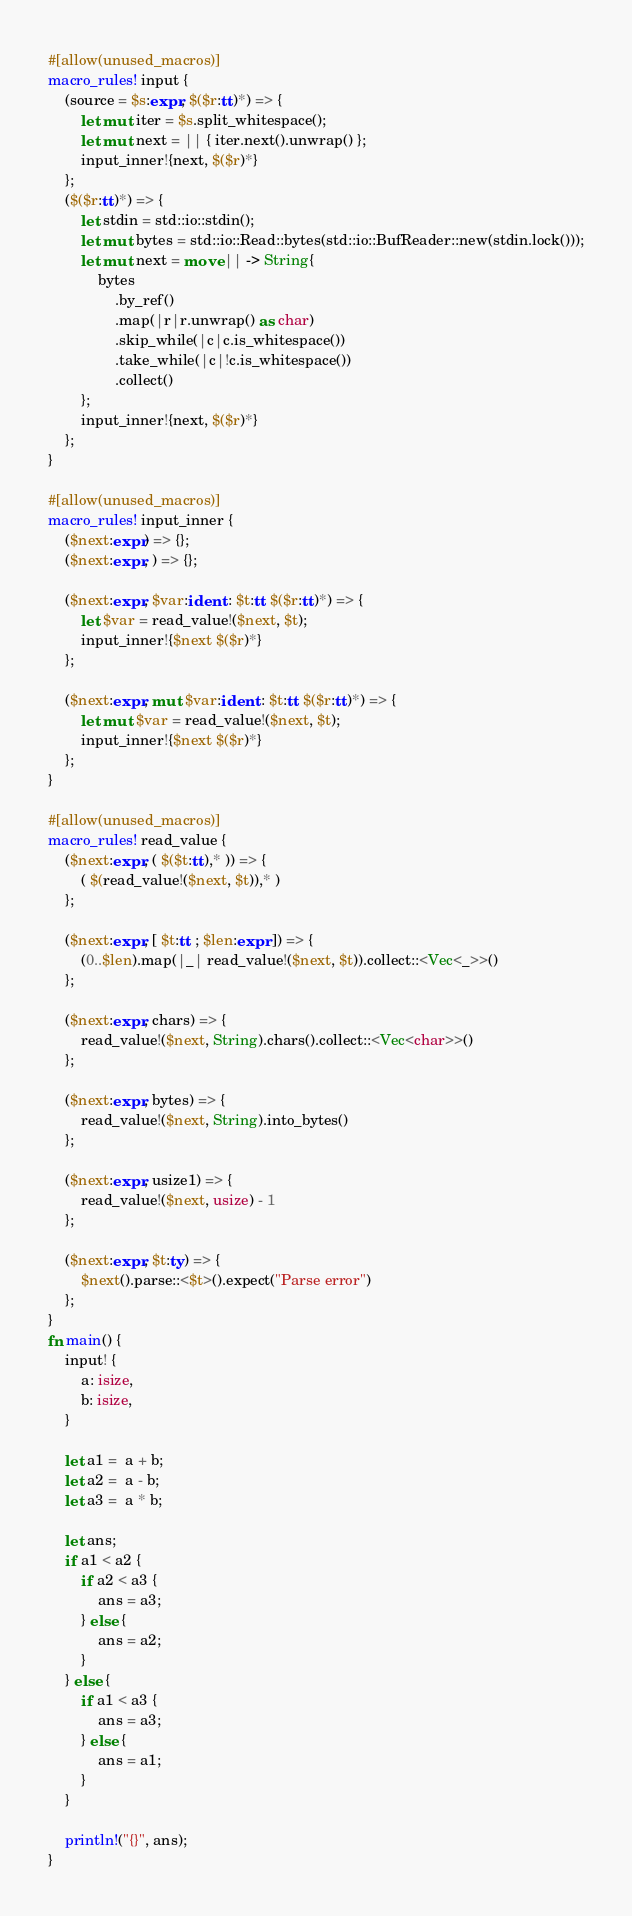<code> <loc_0><loc_0><loc_500><loc_500><_Rust_>#[allow(unused_macros)]
macro_rules! input {
    (source = $s:expr, $($r:tt)*) => {
        let mut iter = $s.split_whitespace();
        let mut next = || { iter.next().unwrap() };
        input_inner!{next, $($r)*}
    };
    ($($r:tt)*) => {
        let stdin = std::io::stdin();
        let mut bytes = std::io::Read::bytes(std::io::BufReader::new(stdin.lock()));
        let mut next = move || -> String{
            bytes
                .by_ref()
                .map(|r|r.unwrap() as char)
                .skip_while(|c|c.is_whitespace())
                .take_while(|c|!c.is_whitespace())
                .collect()
        };
        input_inner!{next, $($r)*}
    };
}
 
#[allow(unused_macros)]
macro_rules! input_inner {
    ($next:expr) => {};
    ($next:expr, ) => {};
 
    ($next:expr, $var:ident : $t:tt $($r:tt)*) => {
        let $var = read_value!($next, $t);
        input_inner!{$next $($r)*}
    };
 
    ($next:expr, mut $var:ident : $t:tt $($r:tt)*) => {
        let mut $var = read_value!($next, $t);
        input_inner!{$next $($r)*}
    };
}
 
#[allow(unused_macros)]
macro_rules! read_value {
    ($next:expr, ( $($t:tt),* )) => {
        ( $(read_value!($next, $t)),* )
    };
 
    ($next:expr, [ $t:tt ; $len:expr ]) => {
        (0..$len).map(|_| read_value!($next, $t)).collect::<Vec<_>>()
    };
 
    ($next:expr, chars) => {
        read_value!($next, String).chars().collect::<Vec<char>>()
    };
 
    ($next:expr, bytes) => {
        read_value!($next, String).into_bytes()
    };
 
    ($next:expr, usize1) => {
        read_value!($next, usize) - 1
    };
 
    ($next:expr, $t:ty) => {
        $next().parse::<$t>().expect("Parse error")
    };
}
fn main() {
    input! {
        a: isize,
        b: isize,
    }

    let a1 =  a + b;
    let a2 =  a - b;
    let a3 =  a * b;

    let ans;
    if a1 < a2 {
        if a2 < a3 {
            ans = a3;
        } else {
            ans = a2;
        }
    } else {
        if a1 < a3 {
            ans = a3;
        } else {
            ans = a1;
        }
    }

    println!("{}", ans);
}
</code> 